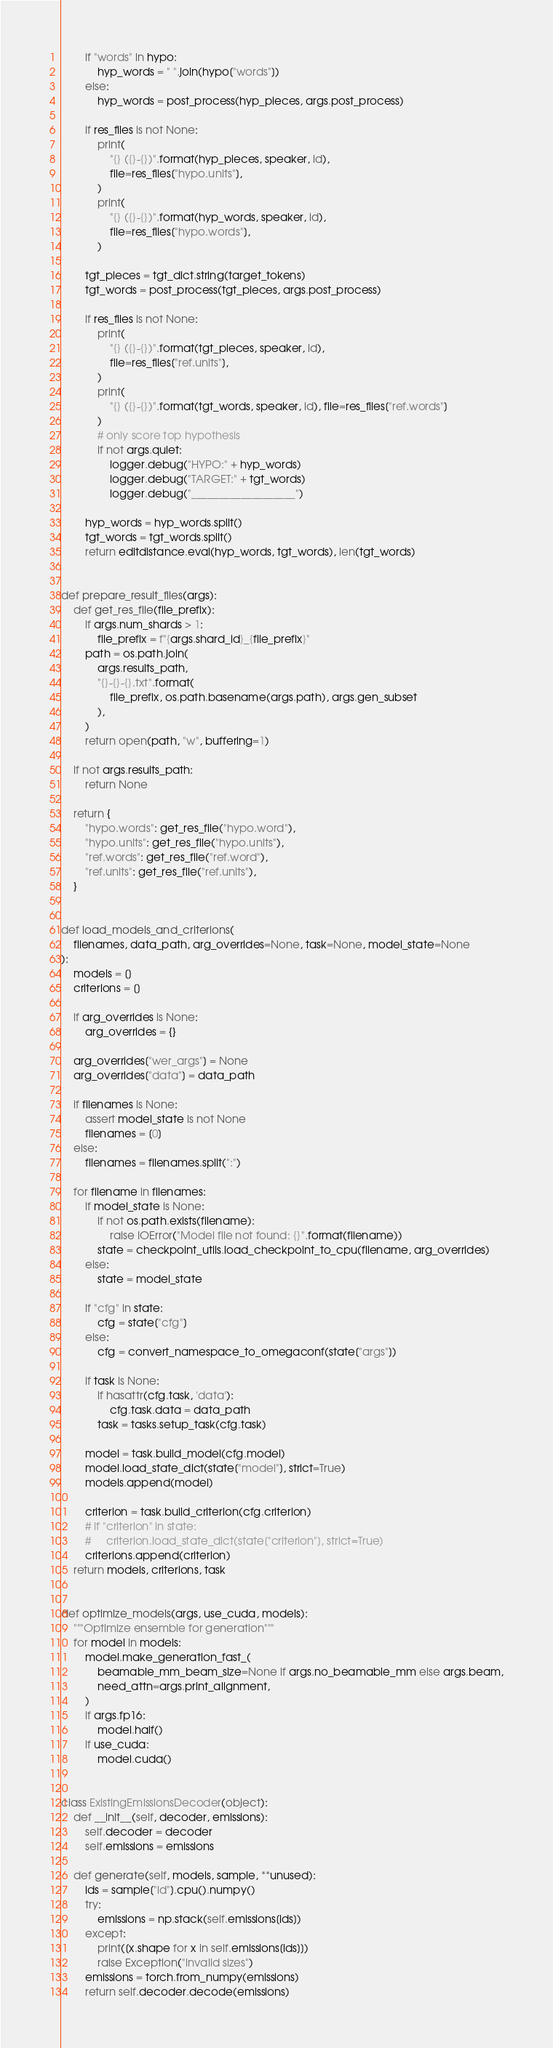<code> <loc_0><loc_0><loc_500><loc_500><_Python_>        if "words" in hypo:
            hyp_words = " ".join(hypo["words"])
        else:
            hyp_words = post_process(hyp_pieces, args.post_process)

        if res_files is not None:
            print(
                "{} ({}-{})".format(hyp_pieces, speaker, id),
                file=res_files["hypo.units"],
            )
            print(
                "{} ({}-{})".format(hyp_words, speaker, id),
                file=res_files["hypo.words"],
            )

        tgt_pieces = tgt_dict.string(target_tokens)
        tgt_words = post_process(tgt_pieces, args.post_process)

        if res_files is not None:
            print(
                "{} ({}-{})".format(tgt_pieces, speaker, id),
                file=res_files["ref.units"],
            )
            print(
                "{} ({}-{})".format(tgt_words, speaker, id), file=res_files["ref.words"]
            )
            # only score top hypothesis
            if not args.quiet:
                logger.debug("HYPO:" + hyp_words)
                logger.debug("TARGET:" + tgt_words)
                logger.debug("___________________")

        hyp_words = hyp_words.split()
        tgt_words = tgt_words.split()
        return editdistance.eval(hyp_words, tgt_words), len(tgt_words)


def prepare_result_files(args):
    def get_res_file(file_prefix):
        if args.num_shards > 1:
            file_prefix = f"{args.shard_id}_{file_prefix}"
        path = os.path.join(
            args.results_path,
            "{}-{}-{}.txt".format(
                file_prefix, os.path.basename(args.path), args.gen_subset
            ),
        )
        return open(path, "w", buffering=1)

    if not args.results_path:
        return None

    return {
        "hypo.words": get_res_file("hypo.word"),
        "hypo.units": get_res_file("hypo.units"),
        "ref.words": get_res_file("ref.word"),
        "ref.units": get_res_file("ref.units"),
    }


def load_models_and_criterions(
    filenames, data_path, arg_overrides=None, task=None, model_state=None
):
    models = []
    criterions = []

    if arg_overrides is None:
        arg_overrides = {}

    arg_overrides["wer_args"] = None
    arg_overrides["data"] = data_path

    if filenames is None:
        assert model_state is not None
        filenames = [0]
    else:
        filenames = filenames.split(":")

    for filename in filenames:
        if model_state is None:
            if not os.path.exists(filename):
                raise IOError("Model file not found: {}".format(filename))
            state = checkpoint_utils.load_checkpoint_to_cpu(filename, arg_overrides)
        else:
            state = model_state

        if "cfg" in state:
            cfg = state["cfg"]
        else:
            cfg = convert_namespace_to_omegaconf(state["args"])

        if task is None:
            if hasattr(cfg.task, 'data'):
                cfg.task.data = data_path
            task = tasks.setup_task(cfg.task)

        model = task.build_model(cfg.model)
        model.load_state_dict(state["model"], strict=True)
        models.append(model)

        criterion = task.build_criterion(cfg.criterion)
        # if "criterion" in state:
        #     criterion.load_state_dict(state["criterion"], strict=True)
        criterions.append(criterion)
    return models, criterions, task


def optimize_models(args, use_cuda, models):
    """Optimize ensemble for generation"""
    for model in models:
        model.make_generation_fast_(
            beamable_mm_beam_size=None if args.no_beamable_mm else args.beam,
            need_attn=args.print_alignment,
        )
        if args.fp16:
            model.half()
        if use_cuda:
            model.cuda()


class ExistingEmissionsDecoder(object):
    def __init__(self, decoder, emissions):
        self.decoder = decoder
        self.emissions = emissions

    def generate(self, models, sample, **unused):
        ids = sample["id"].cpu().numpy()
        try:
            emissions = np.stack(self.emissions[ids])
        except:
            print([x.shape for x in self.emissions[ids]])
            raise Exception("invalid sizes")
        emissions = torch.from_numpy(emissions)
        return self.decoder.decode(emissions)

</code> 